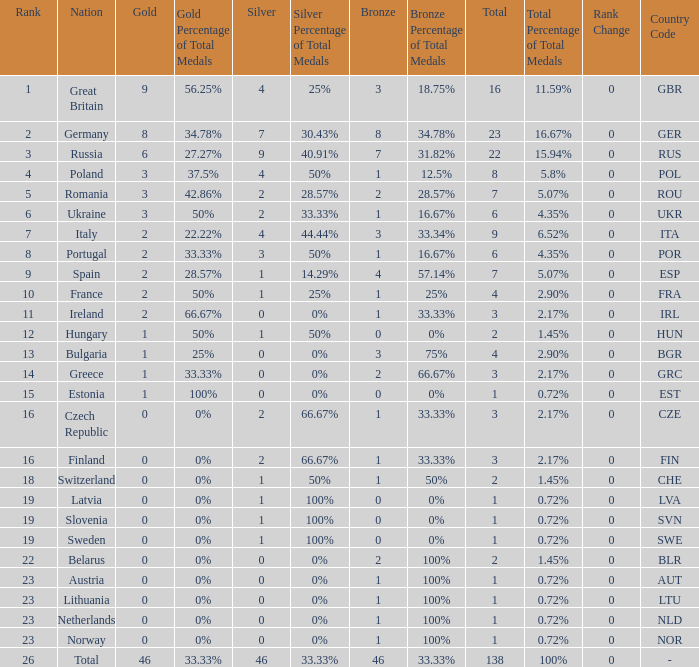What is the average rank when the bronze is larger than 1, and silver is less than 0? None. 